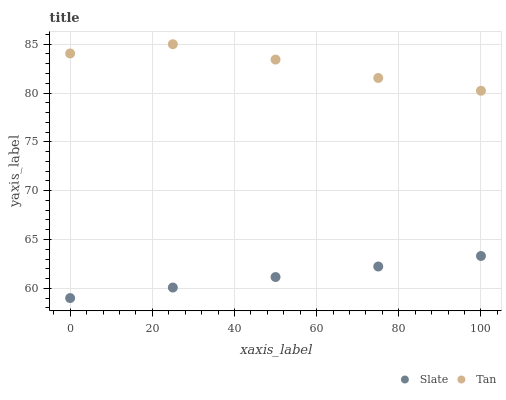Does Slate have the minimum area under the curve?
Answer yes or no. Yes. Does Tan have the maximum area under the curve?
Answer yes or no. Yes. Does Tan have the minimum area under the curve?
Answer yes or no. No. Is Slate the smoothest?
Answer yes or no. Yes. Is Tan the roughest?
Answer yes or no. Yes. Is Tan the smoothest?
Answer yes or no. No. Does Slate have the lowest value?
Answer yes or no. Yes. Does Tan have the lowest value?
Answer yes or no. No. Does Tan have the highest value?
Answer yes or no. Yes. Is Slate less than Tan?
Answer yes or no. Yes. Is Tan greater than Slate?
Answer yes or no. Yes. Does Slate intersect Tan?
Answer yes or no. No. 